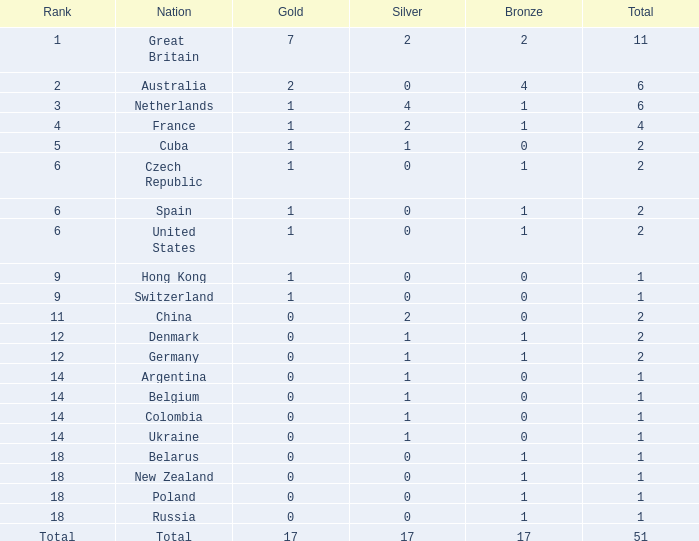What is the position for bronze with less than 17 and gold with less than 1? 11.0. 